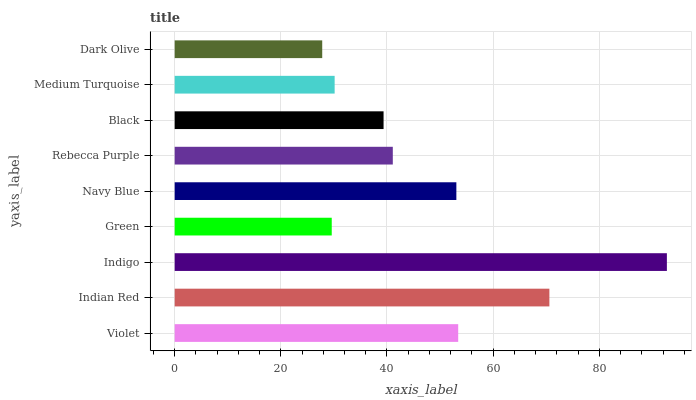Is Dark Olive the minimum?
Answer yes or no. Yes. Is Indigo the maximum?
Answer yes or no. Yes. Is Indian Red the minimum?
Answer yes or no. No. Is Indian Red the maximum?
Answer yes or no. No. Is Indian Red greater than Violet?
Answer yes or no. Yes. Is Violet less than Indian Red?
Answer yes or no. Yes. Is Violet greater than Indian Red?
Answer yes or no. No. Is Indian Red less than Violet?
Answer yes or no. No. Is Rebecca Purple the high median?
Answer yes or no. Yes. Is Rebecca Purple the low median?
Answer yes or no. Yes. Is Indigo the high median?
Answer yes or no. No. Is Dark Olive the low median?
Answer yes or no. No. 